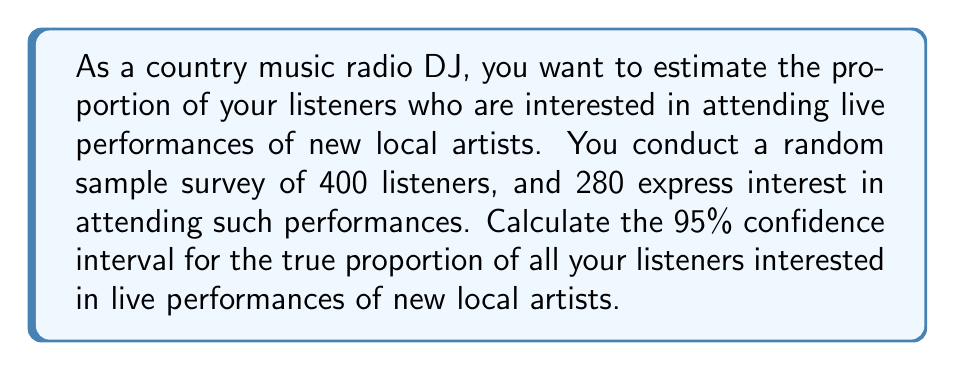Solve this math problem. Let's approach this step-by-step:

1) First, we need to identify the key components:
   - Sample size: $n = 400$
   - Number of successes: $x = 280$
   - Sample proportion: $\hat{p} = \frac{x}{n} = \frac{280}{400} = 0.7$

2) The formula for the confidence interval of a proportion is:

   $$\hat{p} \pm z^* \sqrt{\frac{\hat{p}(1-\hat{p})}{n}}$$

   Where $z^*$ is the critical value for the desired confidence level.

3) For a 95% confidence interval, $z^* = 1.96$

4) Now, let's calculate the margin of error:

   $$\text{ME} = z^* \sqrt{\frac{\hat{p}(1-\hat{p})}{n}}$$
   $$= 1.96 \sqrt{\frac{0.7(1-0.7)}{400}}$$
   $$= 1.96 \sqrt{\frac{0.21}{400}}$$
   $$= 1.96 \sqrt{0.000525}$$
   $$= 1.96 \times 0.0229$$
   $$= 0.0449$$

5) The confidence interval is then:

   $$0.7 \pm 0.0449$$

6) Therefore, the 95% confidence interval is (0.6551, 0.7449)

This means we can be 95% confident that the true proportion of all listeners interested in attending live performances of new local artists is between 65.51% and 74.49%.
Answer: (0.6551, 0.7449) 